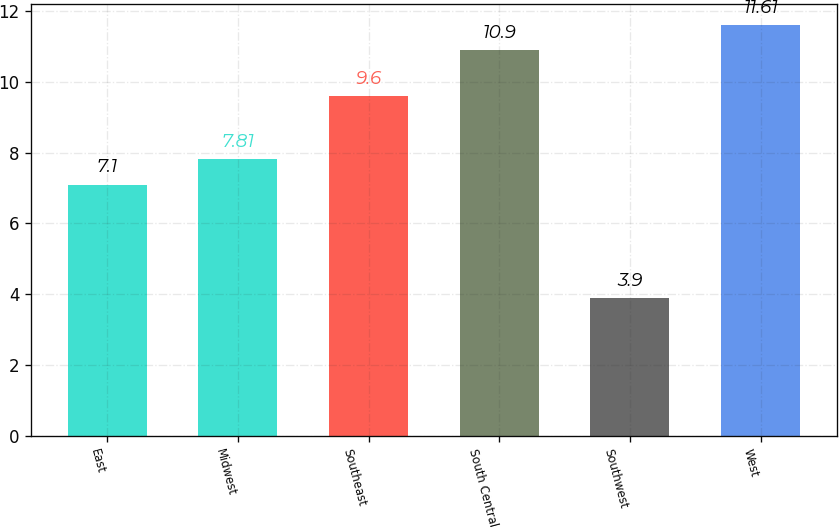<chart> <loc_0><loc_0><loc_500><loc_500><bar_chart><fcel>East<fcel>Midwest<fcel>Southeast<fcel>South Central<fcel>Southwest<fcel>West<nl><fcel>7.1<fcel>7.81<fcel>9.6<fcel>10.9<fcel>3.9<fcel>11.61<nl></chart> 